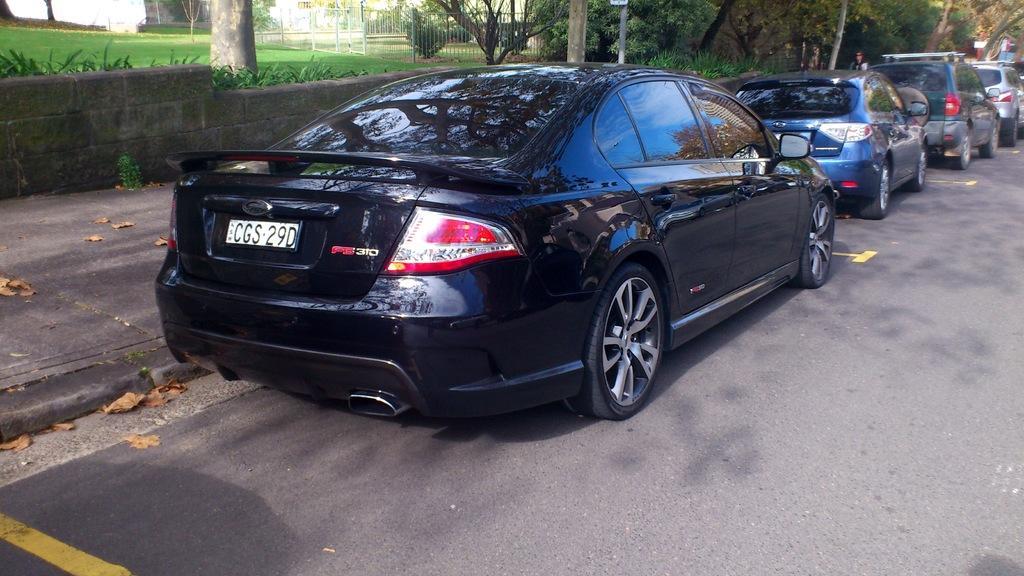How would you summarize this image in a sentence or two? In this image I can see few vehicles. In front the vehicle is in black color, background I can see few trees in green color and I can also see the railing. 